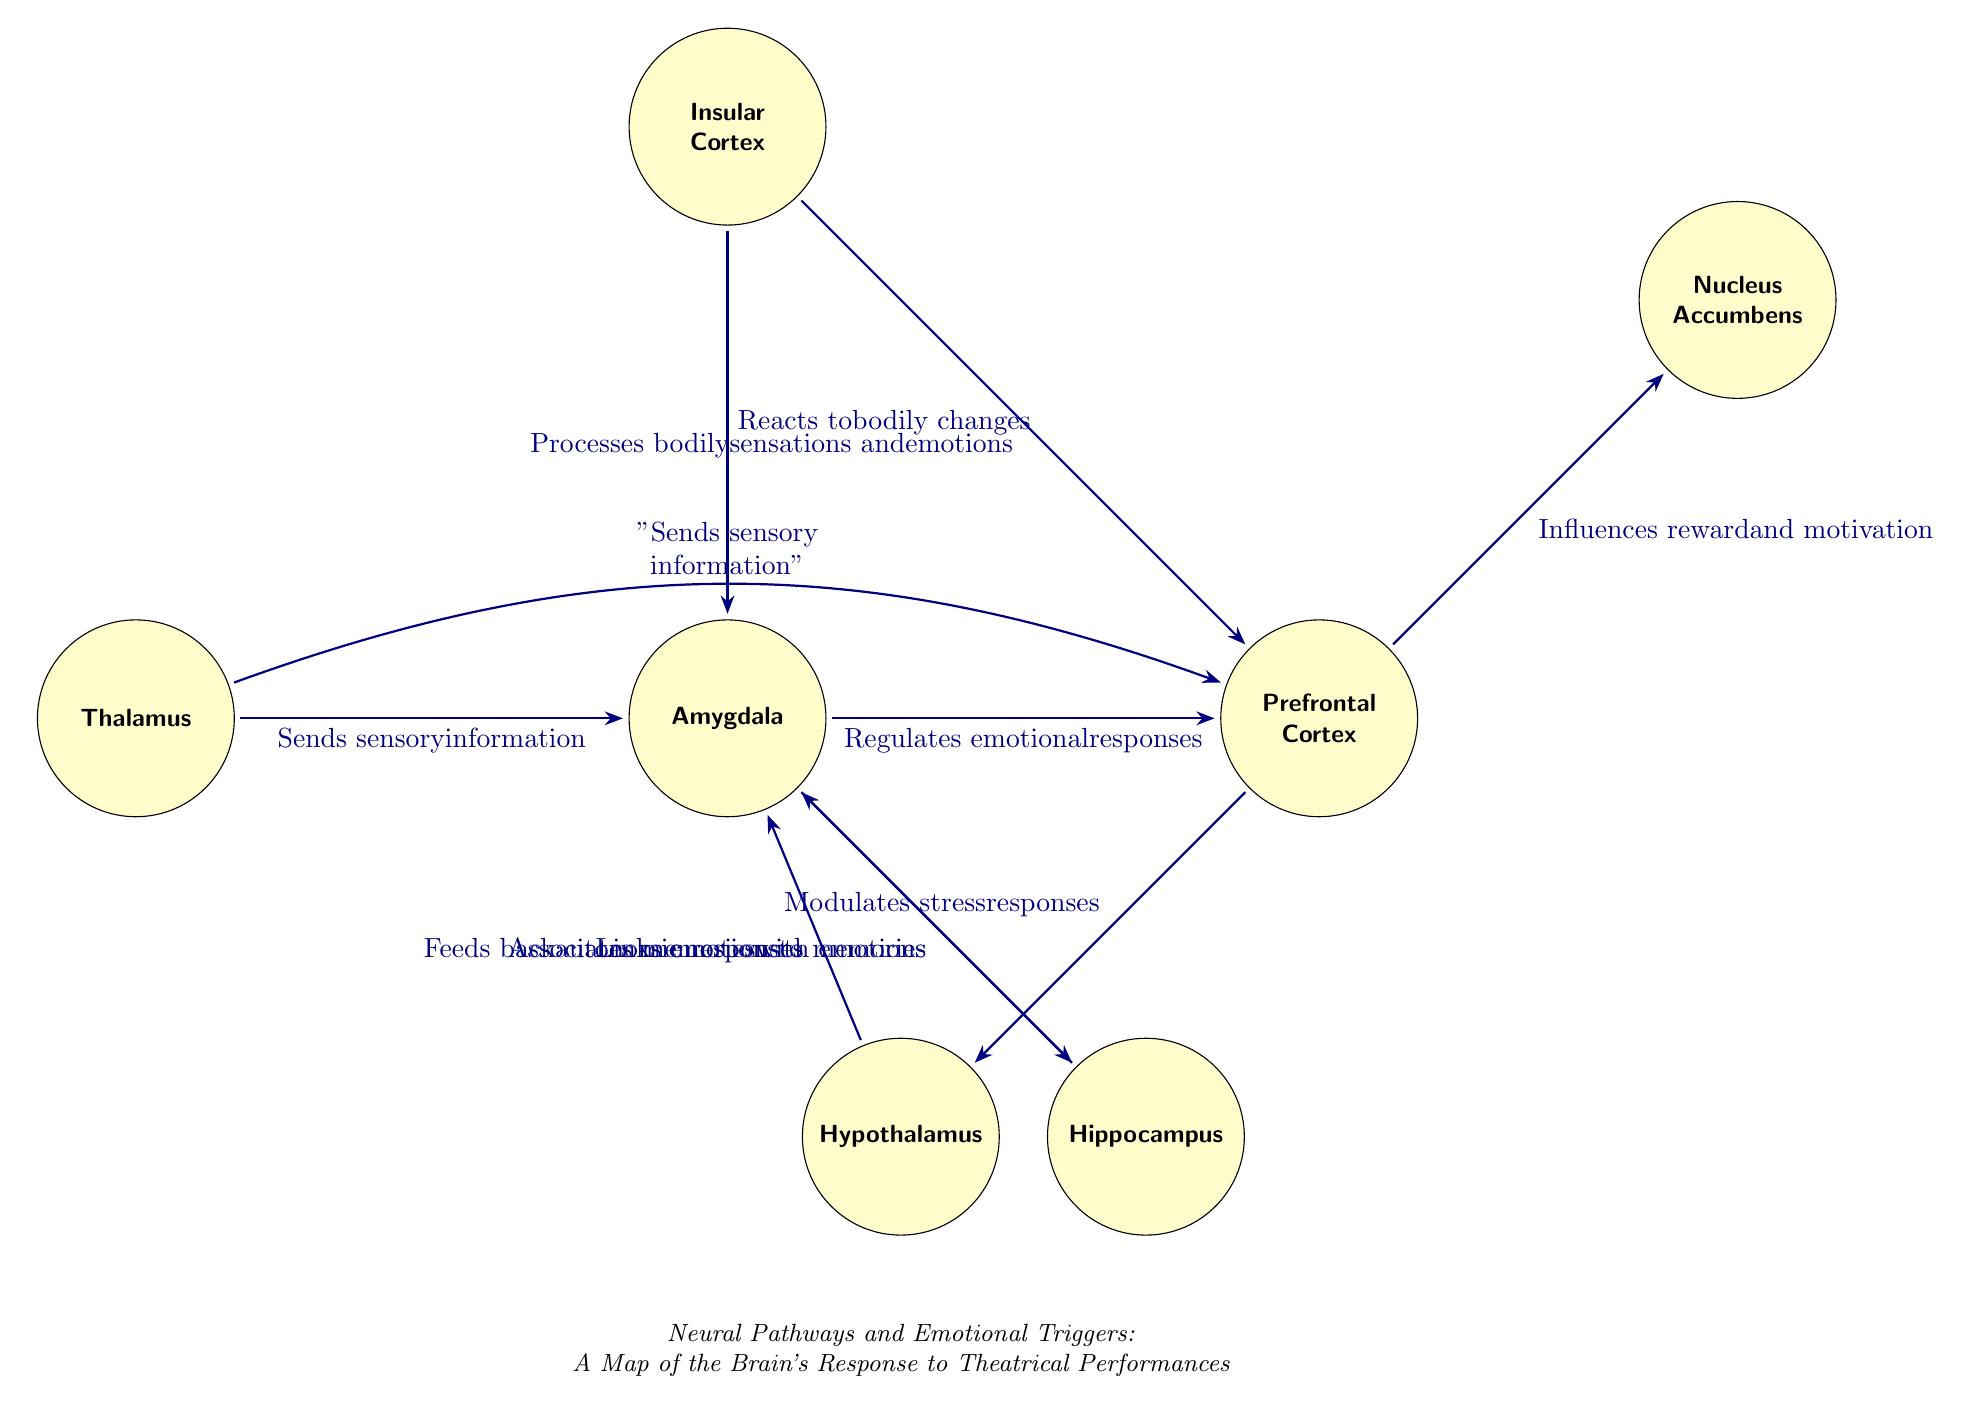What is the role of the Amygdala in emotional responses? The diagram indicates that the Amygdala regulates emotional responses, connecting it to other brain structures.
Answer: Regulates emotional responses How many nodes are present in the diagram? Counting the nodes in the diagram reveals a total of seven distinct brain areas represented.
Answer: 7 What does the Prefrontal Cortex influence according to the diagram? The diagram shows that the Prefrontal Cortex influences reward and motivation as well as modulates stress responses, indicating a key moderated role.
Answer: Reward and motivation Which node sends sensory information to both the Amygdala and the Prefrontal Cortex? The Thalamus is shown to send sensory information to both the Amygdala and the Prefrontal Cortex as indicated by the connections highlighted in the diagram.
Answer: Thalamus How does the Hippocampus associate memories with emotions? The diagram illustrates that the Hippocampus links memories to emotions through its connection with the Amygdala, showing a direct relationship between the two.
Answer: Associates memories with emotions What feedback does the Hypothalamus provide to the Amygdala? According to the diagram, the Hypothalamus feeds back autonomic responses to the Amygdala, indicating a loop between emotional responses and bodily reactions.
Answer: Feeds back autonomic responses How does the Insular Cortex react to bodily changes? The Insular Cortex is depicted in the diagram as reacting specifically to bodily changes, illustrating its role in processing the underlying physical sensations driving emotions.
Answer: Reacts to bodily changes What is the connection between the Thalamus and the Prefrontal Cortex? The Thalamus sends sensory information to the Prefrontal Cortex, which is denoted by a direct relationship in the diagram with a bending connection line.
Answer: Sends sensory information 